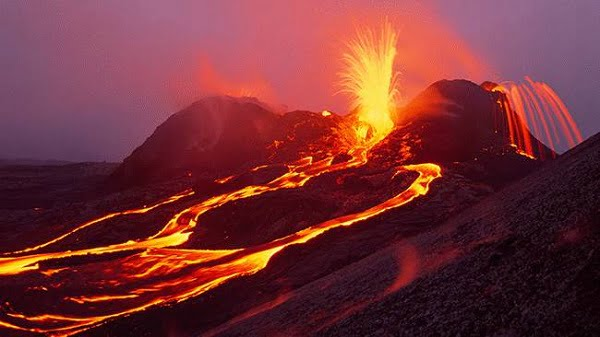Can you explain how volcanic eruptions like the one shown impact the surrounding environment? Volcanic eruptions profoundly affect their environments, altering landscapes and ecosystems. The lava flows can destroy vegetation and animal habitats, creating new land formations as they solidify. Ash and gases released can affect air quality and climate, sometimes even on a global scale. Over time, these areas can also become fertile grounds due to mineral-rich deposits from volcanic materials, eventually leading to new plant growth and revitalized ecosystems. 